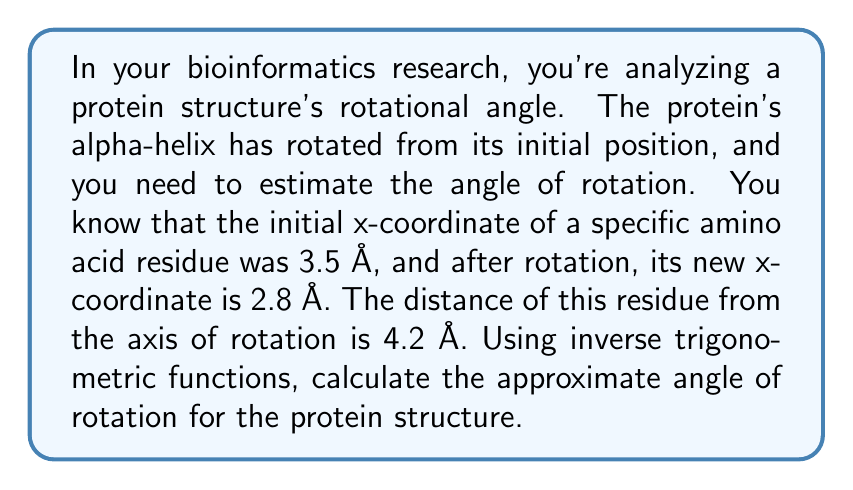Teach me how to tackle this problem. To solve this problem, we'll use the inverse cosine function (arccos) to determine the angle of rotation. Let's break it down step-by-step:

1) First, we need to understand what we're given:
   - Initial x-coordinate: $x_1 = 3.5$ Å
   - Final x-coordinate: $x_2 = 2.8$ Å
   - Distance from rotation axis: $r = 4.2$ Å

2) The change in x-coordinate ($\Delta x$) represents the chord of the circular path:
   $\Delta x = x_1 - x_2 = 3.5 - 2.8 = 0.7$ Å

3) In a circle, the relationship between the chord length ($c$), radius ($r$), and central angle ($\theta$) is given by:
   $c = 2r \sin(\frac{\theta}{2})$

4) In our case, $\Delta x$ is the chord length. So:
   $0.7 = 2(4.2) \sin(\frac{\theta}{2})$

5) Solving for $\sin(\frac{\theta}{2})$:
   $\sin(\frac{\theta}{2}) = \frac{0.7}{2(4.2)} = \frac{0.7}{8.4} \approx 0.0833$

6) To find $\theta$, we need to use the inverse sine function and multiply by 2:
   $\theta = 2 \arcsin(0.0833)$

7) Using a calculator or computer:
   $\theta \approx 2 * 4.78° = 9.56°$

Therefore, the estimated angle of rotation for the protein structure is approximately 9.56°.
Answer: $\theta \approx 9.56°$ 